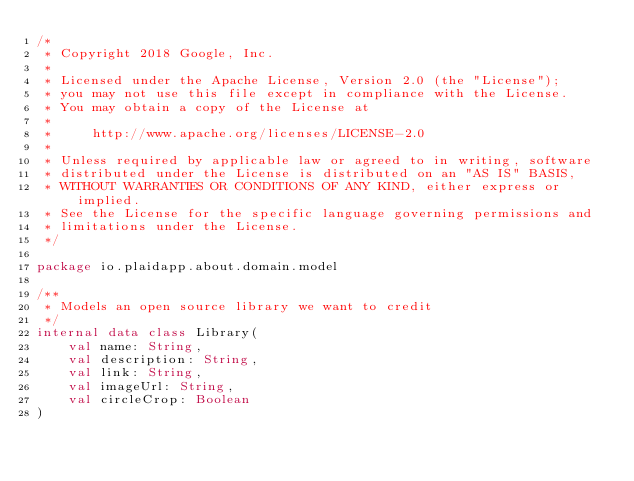<code> <loc_0><loc_0><loc_500><loc_500><_Kotlin_>/*
 * Copyright 2018 Google, Inc.
 *
 * Licensed under the Apache License, Version 2.0 (the "License");
 * you may not use this file except in compliance with the License.
 * You may obtain a copy of the License at
 *
 *     http://www.apache.org/licenses/LICENSE-2.0
 *
 * Unless required by applicable law or agreed to in writing, software
 * distributed under the License is distributed on an "AS IS" BASIS,
 * WITHOUT WARRANTIES OR CONDITIONS OF ANY KIND, either express or implied.
 * See the License for the specific language governing permissions and
 * limitations under the License.
 */

package io.plaidapp.about.domain.model

/**
 * Models an open source library we want to credit
 */
internal data class Library(
    val name: String,
    val description: String,
    val link: String,
    val imageUrl: String,
    val circleCrop: Boolean
)
</code> 